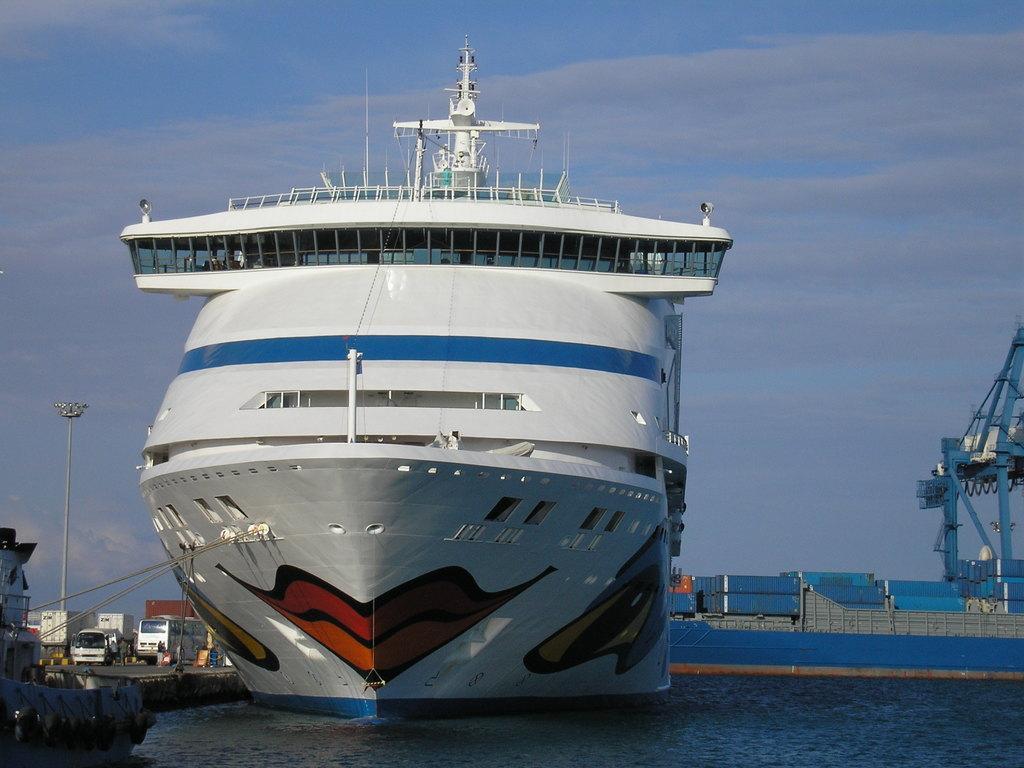In one or two sentences, can you explain what this image depicts? In this picture I can see a ship on the water. In the background I can see the sky. On the right side I can see containers. On the left side I can see vehicles and other objects on the ground. 